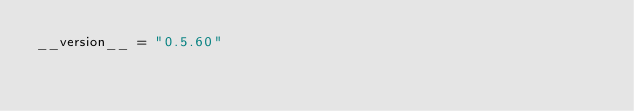<code> <loc_0><loc_0><loc_500><loc_500><_Python_>__version__ = "0.5.60"
</code> 